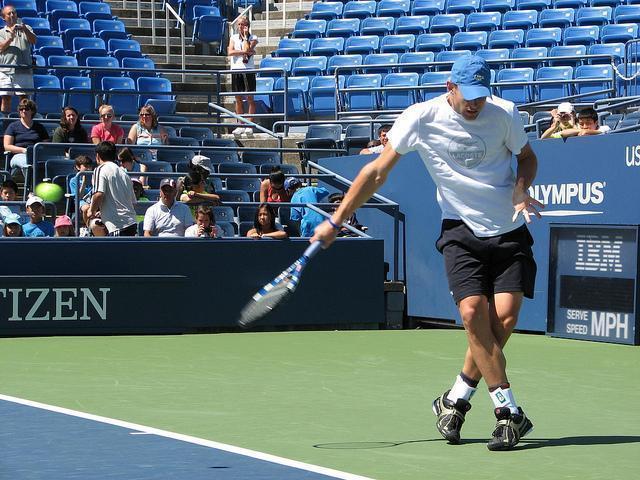What company is sponsoring the speed board?
Choose the right answer and clarify with the format: 'Answer: answer
Rationale: rationale.'
Options: Citizen, geico, ibm, olympus. Answer: ibm.
Rationale: This is the logo displayed above "serve speed mph" on the board. 